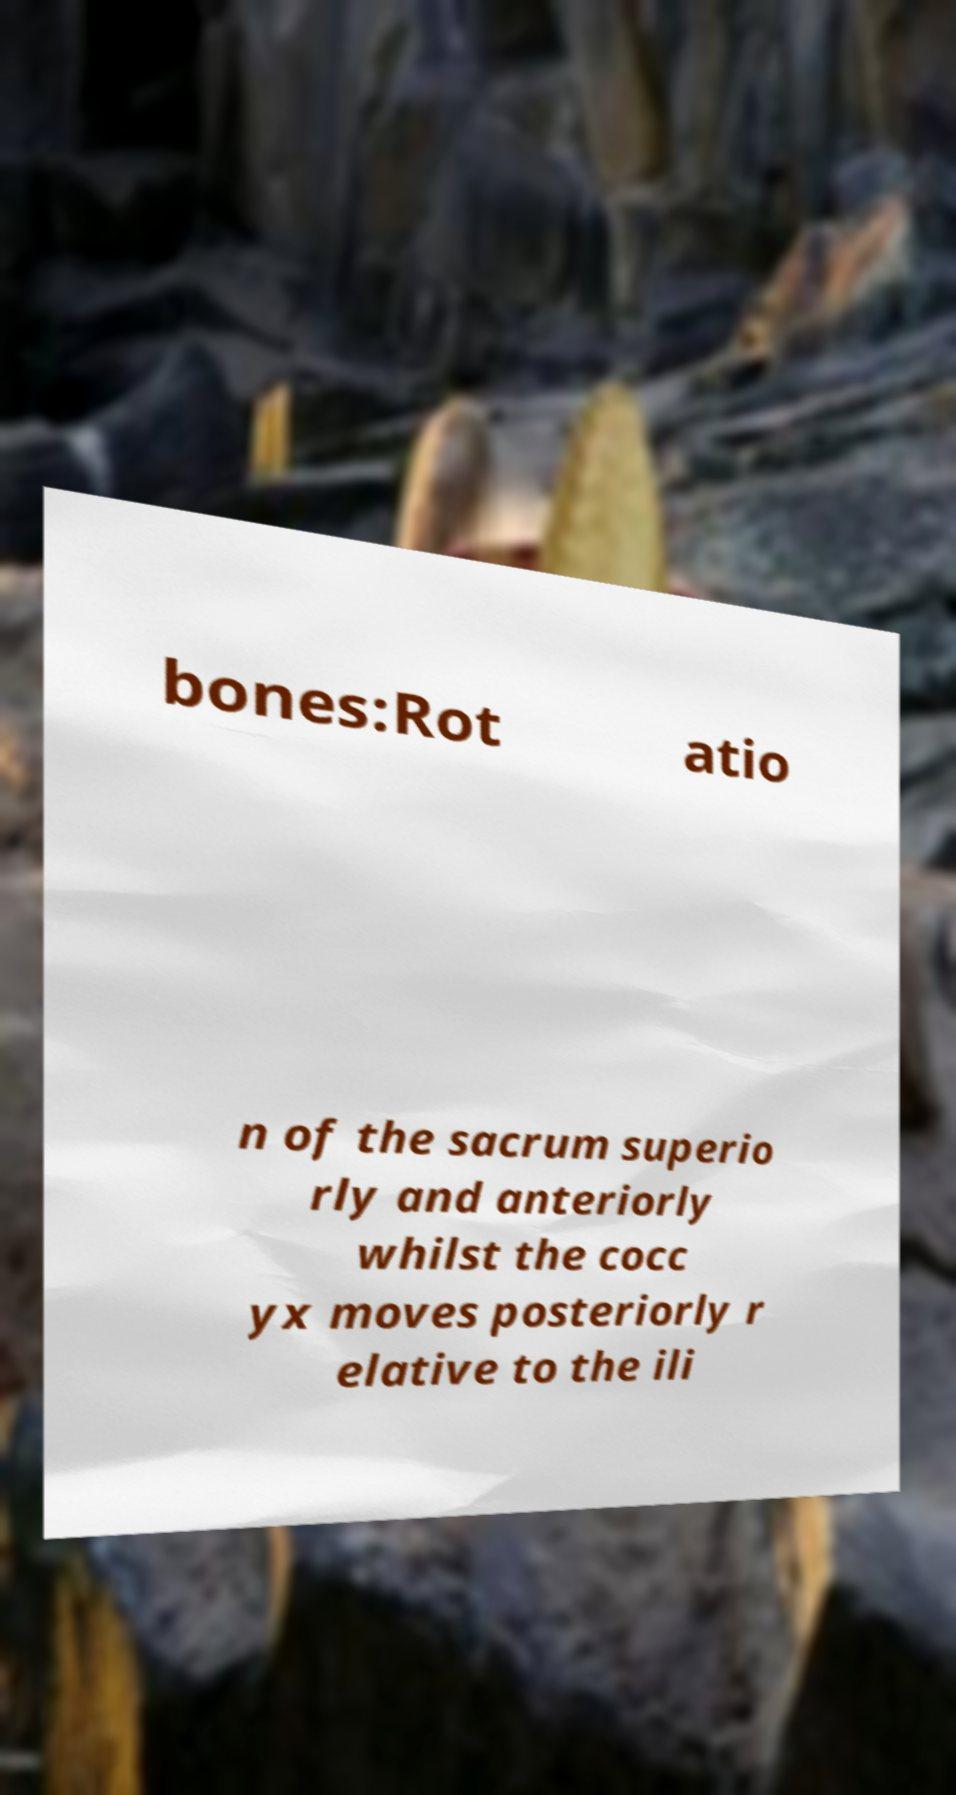Please identify and transcribe the text found in this image. bones:Rot atio n of the sacrum superio rly and anteriorly whilst the cocc yx moves posteriorly r elative to the ili 